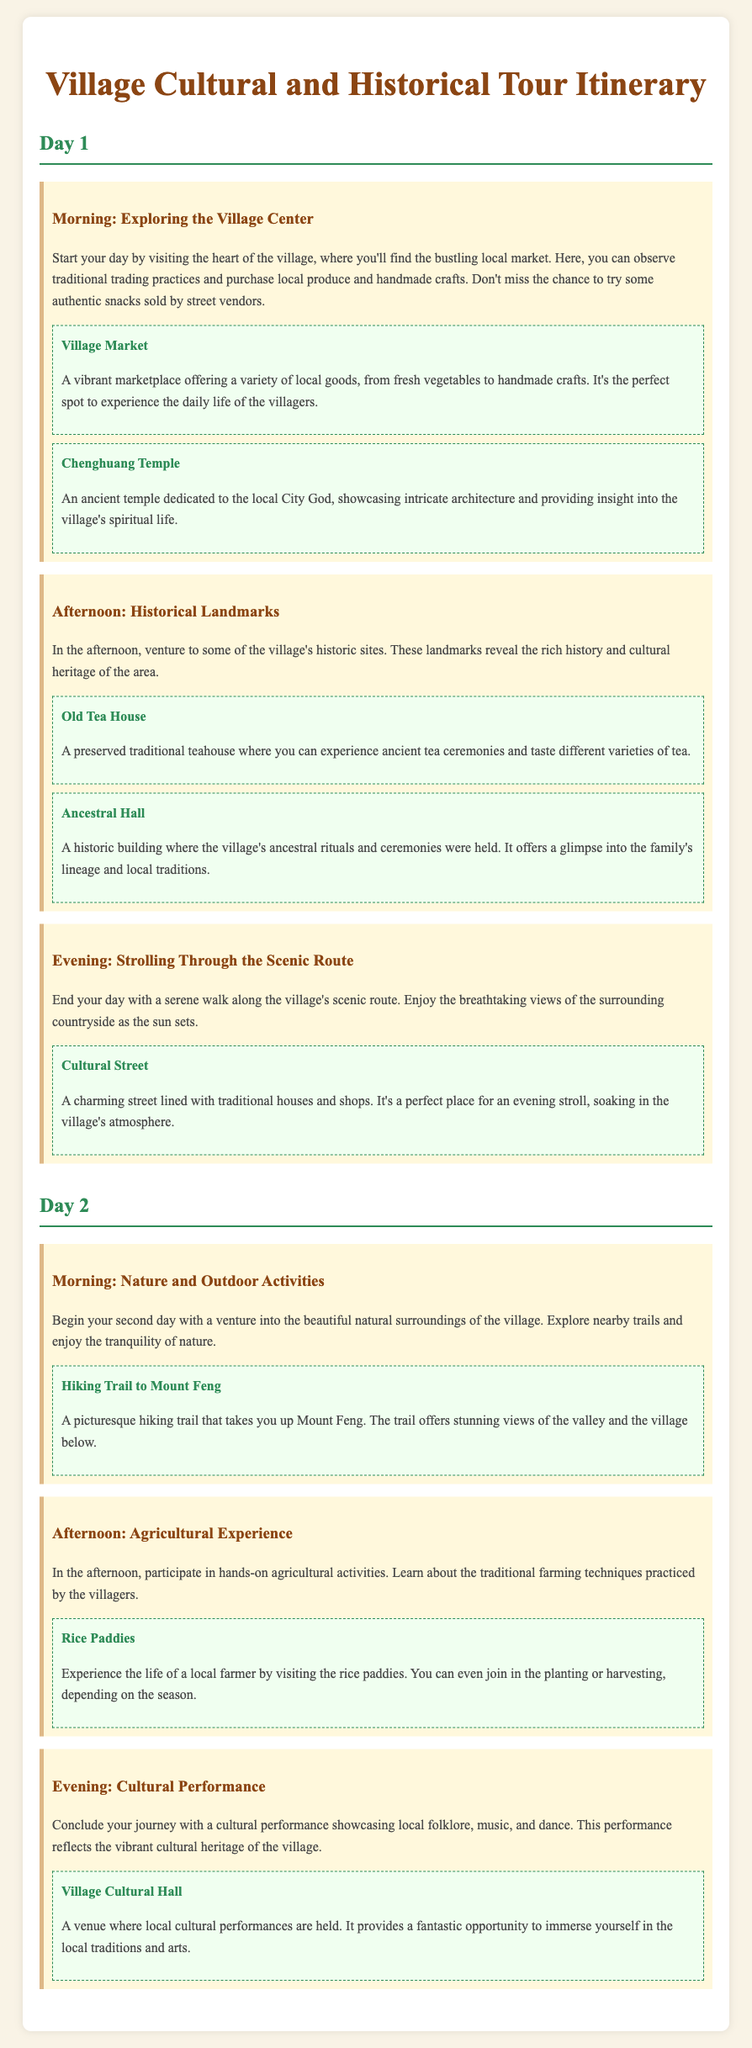what is the title of the document? The title of the document is found in the header section, indicating the purpose of the content.
Answer: Village Cultural and Historical Tour Itinerary how many days does the itinerary cover? The itinerary outlines activities for two distinct days, as indicated by the headings.
Answer: 2 days which landmark is dedicated to the local City God? The document mentions landmarks associated with spiritual significance, specifically indicating one related to the City God.
Answer: Chenghuang Temple what activity takes place in the Village Cultural Hall? The evening activity in the itinerary specifies the type of cultural engagement that occurs in this venue.
Answer: Cultural performance what is the primary focus of the afternoon on Day 2? The document details the activities scheduled for each time segment, highlighting the focus on agriculture.
Answer: Agricultural experience name one traditional item you can find at the Village Market. The document specifies the types of goods available at the market, reflecting local customs and offerings.
Answer: Handmade crafts what scenic feature can be enjoyed during the evening stroll? The document describes a specific aspect of the village's beauty to be appreciated during this activity.
Answer: Breathtaking views what type of tea experience is offered at the Old Tea House? The information regarding the Old Tea House outlines specific cultural practices available there.
Answer: Ancient tea ceremonies how can visitors participate in farming activities? The document explains how visitors can engage with local farming during the agricultural experience.
Answer: Planting or harvesting 